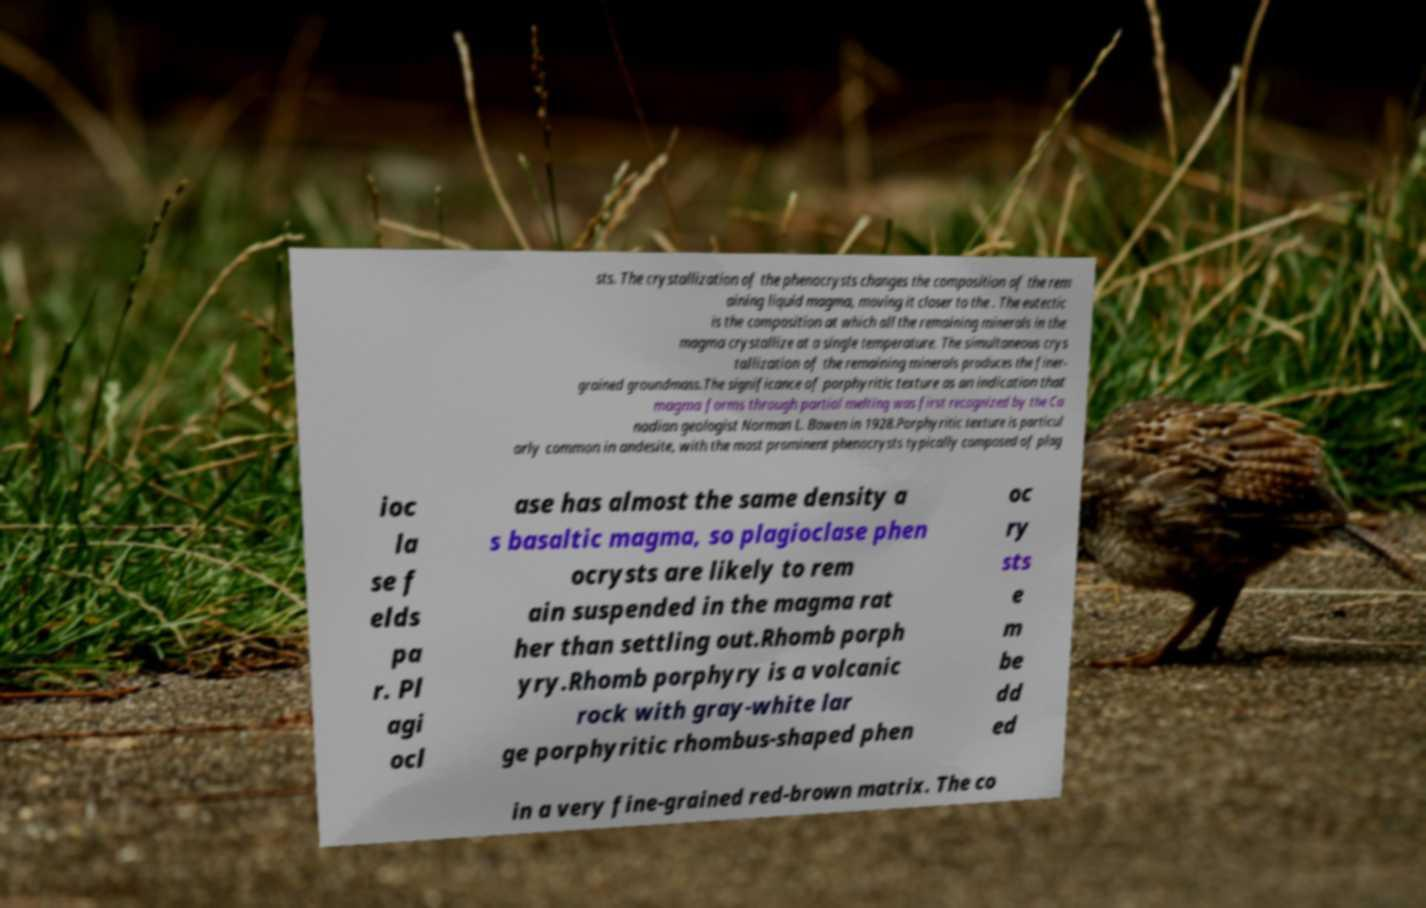Please read and relay the text visible in this image. What does it say? sts. The crystallization of the phenocrysts changes the composition of the rem aining liquid magma, moving it closer to the . The eutectic is the composition at which all the remaining minerals in the magma crystallize at a single temperature. The simultaneous crys tallization of the remaining minerals produces the finer- grained groundmass.The significance of porphyritic texture as an indication that magma forms through partial melting was first recognized by the Ca nadian geologist Norman L. Bowen in 1928.Porphyritic texture is particul arly common in andesite, with the most prominent phenocrysts typically composed of plag ioc la se f elds pa r. Pl agi ocl ase has almost the same density a s basaltic magma, so plagioclase phen ocrysts are likely to rem ain suspended in the magma rat her than settling out.Rhomb porph yry.Rhomb porphyry is a volcanic rock with gray-white lar ge porphyritic rhombus-shaped phen oc ry sts e m be dd ed in a very fine-grained red-brown matrix. The co 